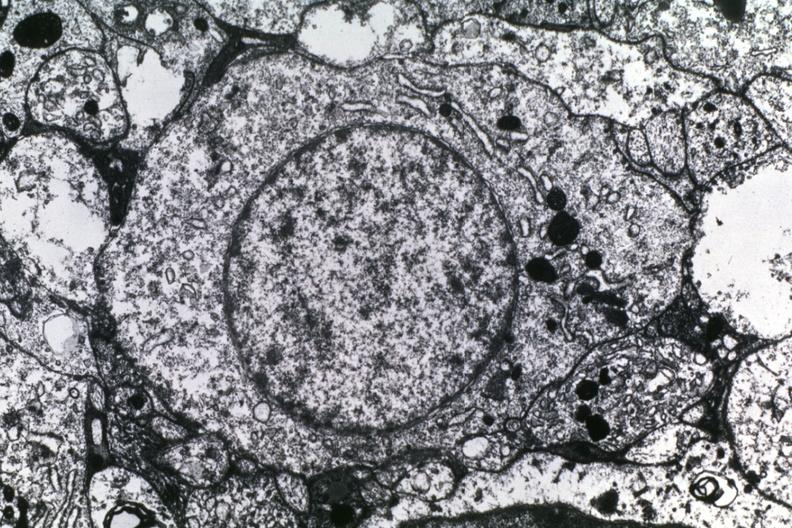what does this image show?
Answer the question using a single word or phrase. Dr garcia tumors 56 